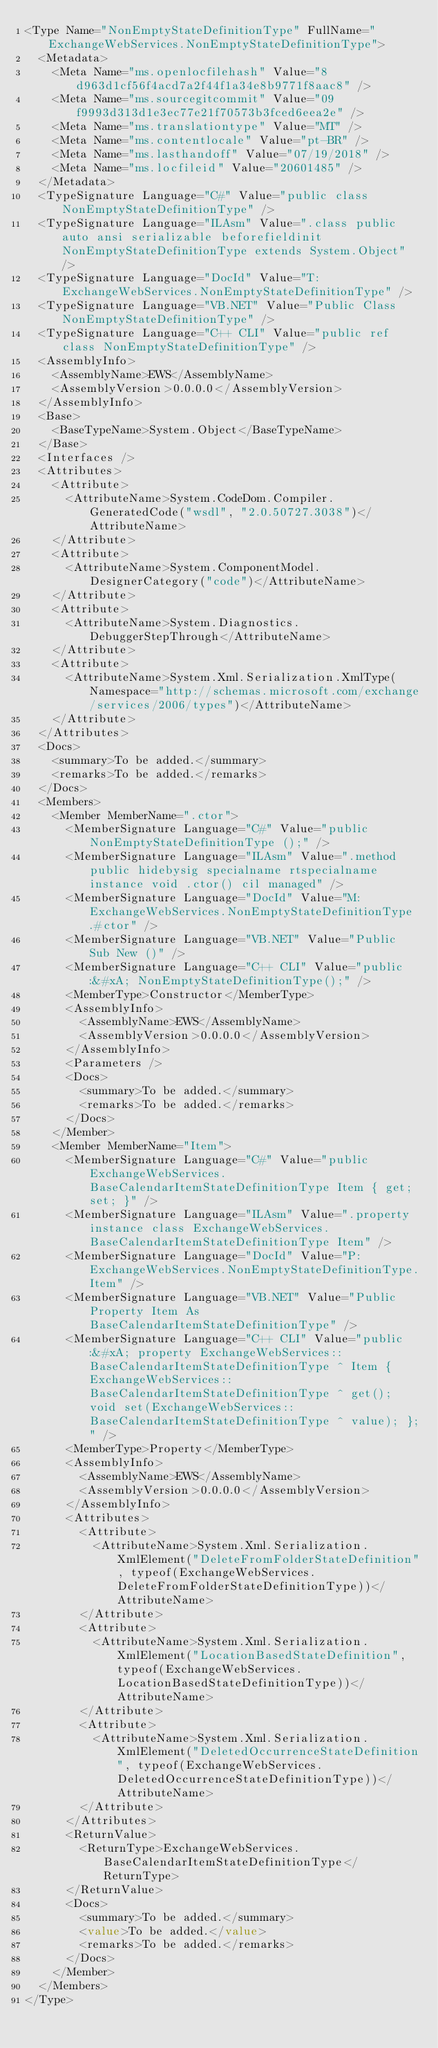Convert code to text. <code><loc_0><loc_0><loc_500><loc_500><_XML_><Type Name="NonEmptyStateDefinitionType" FullName="ExchangeWebServices.NonEmptyStateDefinitionType">
  <Metadata>
    <Meta Name="ms.openlocfilehash" Value="8d963d1cf56f4acd7a2f44f1a34e8b9771f8aac8" />
    <Meta Name="ms.sourcegitcommit" Value="09f9993d313d1e3ec77e21f70573b3fced6eea2e" />
    <Meta Name="ms.translationtype" Value="MT" />
    <Meta Name="ms.contentlocale" Value="pt-BR" />
    <Meta Name="ms.lasthandoff" Value="07/19/2018" />
    <Meta Name="ms.locfileid" Value="20601485" />
  </Metadata>
  <TypeSignature Language="C#" Value="public class NonEmptyStateDefinitionType" />
  <TypeSignature Language="ILAsm" Value=".class public auto ansi serializable beforefieldinit NonEmptyStateDefinitionType extends System.Object" />
  <TypeSignature Language="DocId" Value="T:ExchangeWebServices.NonEmptyStateDefinitionType" />
  <TypeSignature Language="VB.NET" Value="Public Class NonEmptyStateDefinitionType" />
  <TypeSignature Language="C++ CLI" Value="public ref class NonEmptyStateDefinitionType" />
  <AssemblyInfo>
    <AssemblyName>EWS</AssemblyName>
    <AssemblyVersion>0.0.0.0</AssemblyVersion>
  </AssemblyInfo>
  <Base>
    <BaseTypeName>System.Object</BaseTypeName>
  </Base>
  <Interfaces />
  <Attributes>
    <Attribute>
      <AttributeName>System.CodeDom.Compiler.GeneratedCode("wsdl", "2.0.50727.3038")</AttributeName>
    </Attribute>
    <Attribute>
      <AttributeName>System.ComponentModel.DesignerCategory("code")</AttributeName>
    </Attribute>
    <Attribute>
      <AttributeName>System.Diagnostics.DebuggerStepThrough</AttributeName>
    </Attribute>
    <Attribute>
      <AttributeName>System.Xml.Serialization.XmlType(Namespace="http://schemas.microsoft.com/exchange/services/2006/types")</AttributeName>
    </Attribute>
  </Attributes>
  <Docs>
    <summary>To be added.</summary>
    <remarks>To be added.</remarks>
  </Docs>
  <Members>
    <Member MemberName=".ctor">
      <MemberSignature Language="C#" Value="public NonEmptyStateDefinitionType ();" />
      <MemberSignature Language="ILAsm" Value=".method public hidebysig specialname rtspecialname instance void .ctor() cil managed" />
      <MemberSignature Language="DocId" Value="M:ExchangeWebServices.NonEmptyStateDefinitionType.#ctor" />
      <MemberSignature Language="VB.NET" Value="Public Sub New ()" />
      <MemberSignature Language="C++ CLI" Value="public:&#xA; NonEmptyStateDefinitionType();" />
      <MemberType>Constructor</MemberType>
      <AssemblyInfo>
        <AssemblyName>EWS</AssemblyName>
        <AssemblyVersion>0.0.0.0</AssemblyVersion>
      </AssemblyInfo>
      <Parameters />
      <Docs>
        <summary>To be added.</summary>
        <remarks>To be added.</remarks>
      </Docs>
    </Member>
    <Member MemberName="Item">
      <MemberSignature Language="C#" Value="public ExchangeWebServices.BaseCalendarItemStateDefinitionType Item { get; set; }" />
      <MemberSignature Language="ILAsm" Value=".property instance class ExchangeWebServices.BaseCalendarItemStateDefinitionType Item" />
      <MemberSignature Language="DocId" Value="P:ExchangeWebServices.NonEmptyStateDefinitionType.Item" />
      <MemberSignature Language="VB.NET" Value="Public Property Item As BaseCalendarItemStateDefinitionType" />
      <MemberSignature Language="C++ CLI" Value="public:&#xA; property ExchangeWebServices::BaseCalendarItemStateDefinitionType ^ Item { ExchangeWebServices::BaseCalendarItemStateDefinitionType ^ get(); void set(ExchangeWebServices::BaseCalendarItemStateDefinitionType ^ value); };" />
      <MemberType>Property</MemberType>
      <AssemblyInfo>
        <AssemblyName>EWS</AssemblyName>
        <AssemblyVersion>0.0.0.0</AssemblyVersion>
      </AssemblyInfo>
      <Attributes>
        <Attribute>
          <AttributeName>System.Xml.Serialization.XmlElement("DeleteFromFolderStateDefinition", typeof(ExchangeWebServices.DeleteFromFolderStateDefinitionType))</AttributeName>
        </Attribute>
        <Attribute>
          <AttributeName>System.Xml.Serialization.XmlElement("LocationBasedStateDefinition", typeof(ExchangeWebServices.LocationBasedStateDefinitionType))</AttributeName>
        </Attribute>
        <Attribute>
          <AttributeName>System.Xml.Serialization.XmlElement("DeletedOccurrenceStateDefinition", typeof(ExchangeWebServices.DeletedOccurrenceStateDefinitionType))</AttributeName>
        </Attribute>
      </Attributes>
      <ReturnValue>
        <ReturnType>ExchangeWebServices.BaseCalendarItemStateDefinitionType</ReturnType>
      </ReturnValue>
      <Docs>
        <summary>To be added.</summary>
        <value>To be added.</value>
        <remarks>To be added.</remarks>
      </Docs>
    </Member>
  </Members>
</Type></code> 